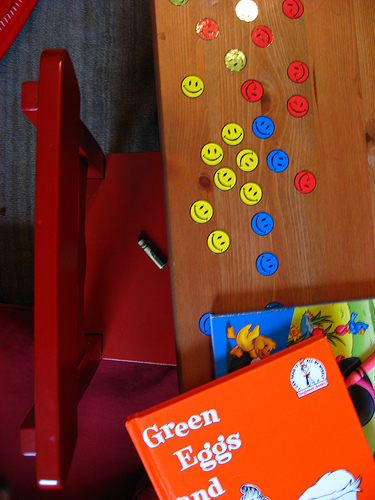<image>
Is the crayon on the chair? Yes. Looking at the image, I can see the crayon is positioned on top of the chair, with the chair providing support. Where is the crayon in relation to the happy face? Is it next to the happy face? No. The crayon is not positioned next to the happy face. They are located in different areas of the scene. 